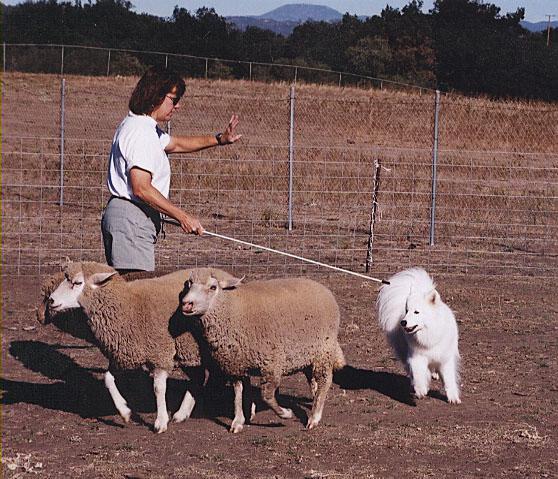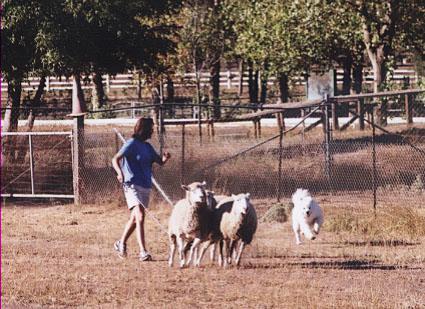The first image is the image on the left, the second image is the image on the right. Considering the images on both sides, is "A white dog is in an enclosure working with sheep." valid? Answer yes or no. Yes. The first image is the image on the left, the second image is the image on the right. Examine the images to the left and right. Is the description "At least one image shows a woman holding a stick while working with sheep and dog." accurate? Answer yes or no. Yes. 